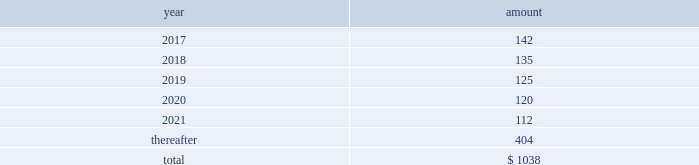Future payments that will not be paid because of an early redemption , which is discounted at a fixed spread over a comparable treasury security .
The unamortized discount and debt issuance costs are being amortized over the remaining term of the 2022 notes .
2021 notes .
In may 2011 , the company issued $ 1.5 billion in aggregate principal amount of unsecured unsubordinated obligations .
These notes were issued as two separate series of senior debt securities , including $ 750 million of 4.25% ( 4.25 % ) notes maturing in may 2021 and $ 750 million of floating rate notes , which were repaid in may 2013 at maturity .
Net proceeds of this offering were used to fund the repurchase of blackrock 2019s series b preferred from affiliates of merrill lynch & co. , inc .
Interest on the 4.25% ( 4.25 % ) notes due in 2021 ( 201c2021 notes 201d ) is payable semi-annually on may 24 and november 24 of each year , which commenced november 24 , 2011 , and is approximately $ 32 million per year .
The 2021 notes may be redeemed prior to maturity at any time in whole or in part at the option of the company at a 201cmake-whole 201d redemption price .
The unamortized discount and debt issuance costs are being amortized over the remaining term of the 2021 notes .
2019 notes .
In december 2009 , the company issued $ 2.5 billion in aggregate principal amount of unsecured and unsubordinated obligations .
These notes were issued as three separate series of senior debt securities including $ 0.5 billion of 2.25% ( 2.25 % ) notes , which were repaid in december 2012 , $ 1.0 billion of 3.50% ( 3.50 % ) notes , which were repaid in december 2014 at maturity , and $ 1.0 billion of 5.0% ( 5.0 % ) notes maturing in december 2019 ( the 201c2019 notes 201d ) .
Net proceeds of this offering were used to repay borrowings under the cp program , which was used to finance a portion of the acquisition of barclays global investors from barclays on december 1 , 2009 , and for general corporate purposes .
Interest on the 2019 notes of approximately $ 50 million per year is payable semi-annually in arrears on june 10 and december 10 of each year .
These notes may be redeemed prior to maturity at any time in whole or in part at the option of the company at a 201cmake-whole 201d redemption price .
The unamortized discount and debt issuance costs are being amortized over the remaining term of the 2019 notes .
2017 notes .
In september 2007 , the company issued $ 700 million in aggregate principal amount of 6.25% ( 6.25 % ) senior unsecured and unsubordinated notes maturing on september 15 , 2017 ( the 201c2017 notes 201d ) .
A portion of the net proceeds of the 2017 notes was used to fund the initial cash payment for the acquisition of the fund-of-funds business of quellos and the remainder was used for general corporate purposes .
Interest is payable semi-annually in arrears on march 15 and september 15 of each year , or approximately $ 44 million per year .
The 2017 notes may be redeemed prior to maturity at any time in whole or in part at the option of the company at a 201cmake-whole 201d redemption price .
The unamortized discount and debt issuance costs are being amortized over the remaining term of the 2017 notes .
13 .
Commitments and contingencies operating lease commitments the company leases its primary office spaces under agreements that expire through 2035 .
Future minimum commitments under these operating leases are as follows : ( in millions ) .
Rent expense and certain office equipment expense under lease agreements amounted to $ 134 million , $ 136 million and $ 132 million in 2016 , 2015 and 2014 , respectively .
Investment commitments .
At december 31 , 2016 , the company had $ 192 million of various capital commitments to fund sponsored investment funds , including consolidated vies .
These funds include private equity funds , real assets funds , and opportunistic funds .
This amount excludes additional commitments made by consolidated funds of funds to underlying third-party funds as third-party noncontrolling interest holders have the legal obligation to fund the respective commitments of such funds of funds .
In addition to the capital commitments of $ 192 million , the company had approximately $ 12 million of contingent commitments for certain funds which have investment periods that have expired .
Generally , the timing of the funding of these commitments is unknown and the commitments are callable on demand at any time prior to the expiration of the commitment .
These unfunded commitments are not recorded on the consolidated statements of financial condition .
These commitments do not include potential future commitments approved by the company that are not yet legally binding .
The company intends to make additional capital commitments from time to time to fund additional investment products for , and with , its clients .
Contingencies contingent payments related to business acquisitions .
In connection with certain acquisitions , blackrock is required to make contingent payments , subject to achieving specified performance targets , which may include revenue related to acquired contracts or new capital commitments for certain products .
The fair value of the remaining aggregate contingent payments at december 31 , 2016 totaled $ 115 million and is included in other liabilities on the consolidated statement of financial condition .
Other contingent payments .
The company acts as the portfolio manager in a series of derivative transactions and has a maximum potential exposure of $ 17 million between the company and counterparty .
See note 7 , derivatives and hedging , for further discussion .
Legal proceedings .
From time to time , blackrock receives subpoenas or other requests for information from various u.s .
Federal , state governmental and domestic and international regulatory authorities in connection with .
What are the future minimum commitments under the operating leases in 2017 as a percentage of the total future minimum commitments under the operating leases? 
Computations: (142 / 1038)
Answer: 0.1368. Future payments that will not be paid because of an early redemption , which is discounted at a fixed spread over a comparable treasury security .
The unamortized discount and debt issuance costs are being amortized over the remaining term of the 2022 notes .
2021 notes .
In may 2011 , the company issued $ 1.5 billion in aggregate principal amount of unsecured unsubordinated obligations .
These notes were issued as two separate series of senior debt securities , including $ 750 million of 4.25% ( 4.25 % ) notes maturing in may 2021 and $ 750 million of floating rate notes , which were repaid in may 2013 at maturity .
Net proceeds of this offering were used to fund the repurchase of blackrock 2019s series b preferred from affiliates of merrill lynch & co. , inc .
Interest on the 4.25% ( 4.25 % ) notes due in 2021 ( 201c2021 notes 201d ) is payable semi-annually on may 24 and november 24 of each year , which commenced november 24 , 2011 , and is approximately $ 32 million per year .
The 2021 notes may be redeemed prior to maturity at any time in whole or in part at the option of the company at a 201cmake-whole 201d redemption price .
The unamortized discount and debt issuance costs are being amortized over the remaining term of the 2021 notes .
2019 notes .
In december 2009 , the company issued $ 2.5 billion in aggregate principal amount of unsecured and unsubordinated obligations .
These notes were issued as three separate series of senior debt securities including $ 0.5 billion of 2.25% ( 2.25 % ) notes , which were repaid in december 2012 , $ 1.0 billion of 3.50% ( 3.50 % ) notes , which were repaid in december 2014 at maturity , and $ 1.0 billion of 5.0% ( 5.0 % ) notes maturing in december 2019 ( the 201c2019 notes 201d ) .
Net proceeds of this offering were used to repay borrowings under the cp program , which was used to finance a portion of the acquisition of barclays global investors from barclays on december 1 , 2009 , and for general corporate purposes .
Interest on the 2019 notes of approximately $ 50 million per year is payable semi-annually in arrears on june 10 and december 10 of each year .
These notes may be redeemed prior to maturity at any time in whole or in part at the option of the company at a 201cmake-whole 201d redemption price .
The unamortized discount and debt issuance costs are being amortized over the remaining term of the 2019 notes .
2017 notes .
In september 2007 , the company issued $ 700 million in aggregate principal amount of 6.25% ( 6.25 % ) senior unsecured and unsubordinated notes maturing on september 15 , 2017 ( the 201c2017 notes 201d ) .
A portion of the net proceeds of the 2017 notes was used to fund the initial cash payment for the acquisition of the fund-of-funds business of quellos and the remainder was used for general corporate purposes .
Interest is payable semi-annually in arrears on march 15 and september 15 of each year , or approximately $ 44 million per year .
The 2017 notes may be redeemed prior to maturity at any time in whole or in part at the option of the company at a 201cmake-whole 201d redemption price .
The unamortized discount and debt issuance costs are being amortized over the remaining term of the 2017 notes .
13 .
Commitments and contingencies operating lease commitments the company leases its primary office spaces under agreements that expire through 2035 .
Future minimum commitments under these operating leases are as follows : ( in millions ) .
Rent expense and certain office equipment expense under lease agreements amounted to $ 134 million , $ 136 million and $ 132 million in 2016 , 2015 and 2014 , respectively .
Investment commitments .
At december 31 , 2016 , the company had $ 192 million of various capital commitments to fund sponsored investment funds , including consolidated vies .
These funds include private equity funds , real assets funds , and opportunistic funds .
This amount excludes additional commitments made by consolidated funds of funds to underlying third-party funds as third-party noncontrolling interest holders have the legal obligation to fund the respective commitments of such funds of funds .
In addition to the capital commitments of $ 192 million , the company had approximately $ 12 million of contingent commitments for certain funds which have investment periods that have expired .
Generally , the timing of the funding of these commitments is unknown and the commitments are callable on demand at any time prior to the expiration of the commitment .
These unfunded commitments are not recorded on the consolidated statements of financial condition .
These commitments do not include potential future commitments approved by the company that are not yet legally binding .
The company intends to make additional capital commitments from time to time to fund additional investment products for , and with , its clients .
Contingencies contingent payments related to business acquisitions .
In connection with certain acquisitions , blackrock is required to make contingent payments , subject to achieving specified performance targets , which may include revenue related to acquired contracts or new capital commitments for certain products .
The fair value of the remaining aggregate contingent payments at december 31 , 2016 totaled $ 115 million and is included in other liabilities on the consolidated statement of financial condition .
Other contingent payments .
The company acts as the portfolio manager in a series of derivative transactions and has a maximum potential exposure of $ 17 million between the company and counterparty .
See note 7 , derivatives and hedging , for further discussion .
Legal proceedings .
From time to time , blackrock receives subpoenas or other requests for information from various u.s .
Federal , state governmental and domestic and international regulatory authorities in connection with .
What are the various capital commitments to fund sponsored investment funds as a percentage of the total future minimum commitments under the operating leases? 
Computations: (192 / 1038)
Answer: 0.18497. 